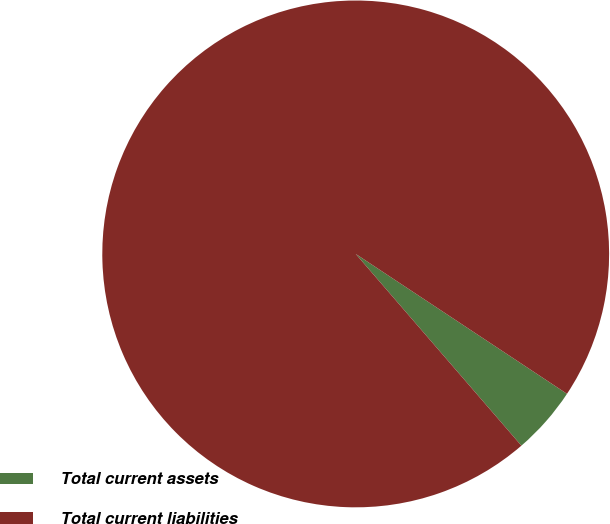<chart> <loc_0><loc_0><loc_500><loc_500><pie_chart><fcel>Total current assets<fcel>Total current liabilities<nl><fcel>4.35%<fcel>95.65%<nl></chart> 